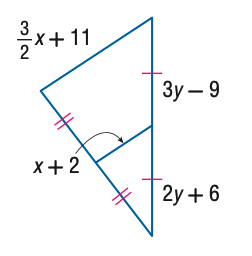Answer the mathemtical geometry problem and directly provide the correct option letter.
Question: Find y.
Choices: A: 13 B: 14 C: 15 D: 16 C 